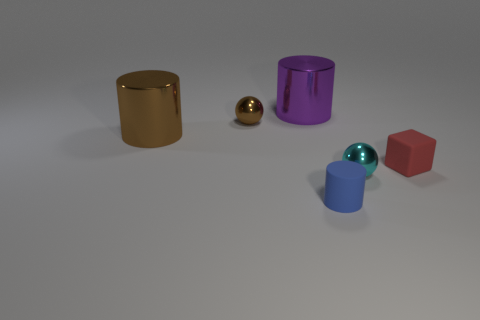Are there any other things that are the same shape as the red object?
Keep it short and to the point. No. What material is the red cube?
Keep it short and to the point. Rubber. How many other objects are the same size as the blue matte object?
Provide a succinct answer. 3. There is a cylinder on the left side of the big purple shiny cylinder; what size is it?
Give a very brief answer. Large. There is a brown ball on the left side of the blue rubber object that is to the left of the metallic sphere to the right of the tiny blue matte object; what is it made of?
Your answer should be compact. Metal. Is the tiny cyan object the same shape as the small brown metallic object?
Provide a short and direct response. Yes. How many matte objects are either tiny brown things or small yellow objects?
Your answer should be compact. 0. What number of blue things are there?
Keep it short and to the point. 1. What is the color of the other matte thing that is the same size as the red rubber object?
Your answer should be compact. Blue. Does the purple metallic cylinder have the same size as the brown shiny cylinder?
Offer a very short reply. Yes. 